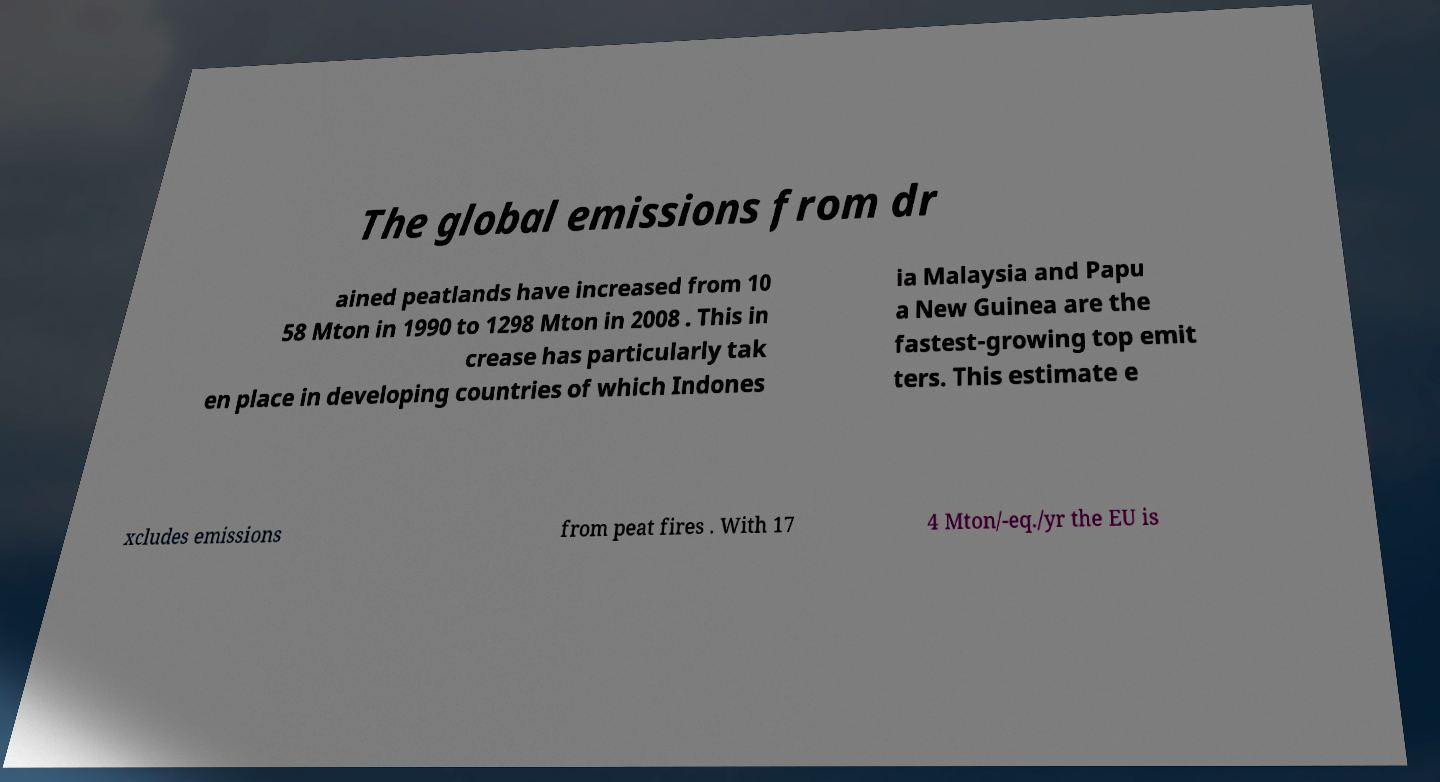Could you assist in decoding the text presented in this image and type it out clearly? The global emissions from dr ained peatlands have increased from 10 58 Mton in 1990 to 1298 Mton in 2008 . This in crease has particularly tak en place in developing countries of which Indones ia Malaysia and Papu a New Guinea are the fastest-growing top emit ters. This estimate e xcludes emissions from peat fires . With 17 4 Mton/-eq./yr the EU is 